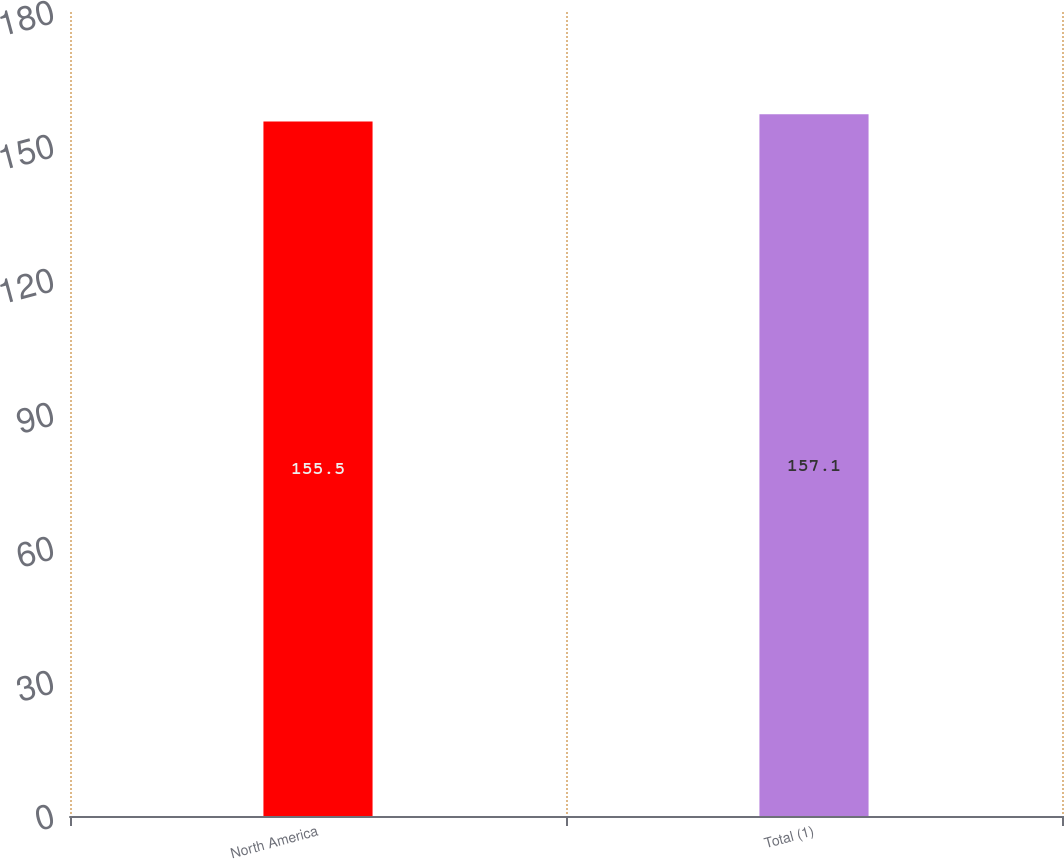<chart> <loc_0><loc_0><loc_500><loc_500><bar_chart><fcel>North America<fcel>Total (1)<nl><fcel>155.5<fcel>157.1<nl></chart> 